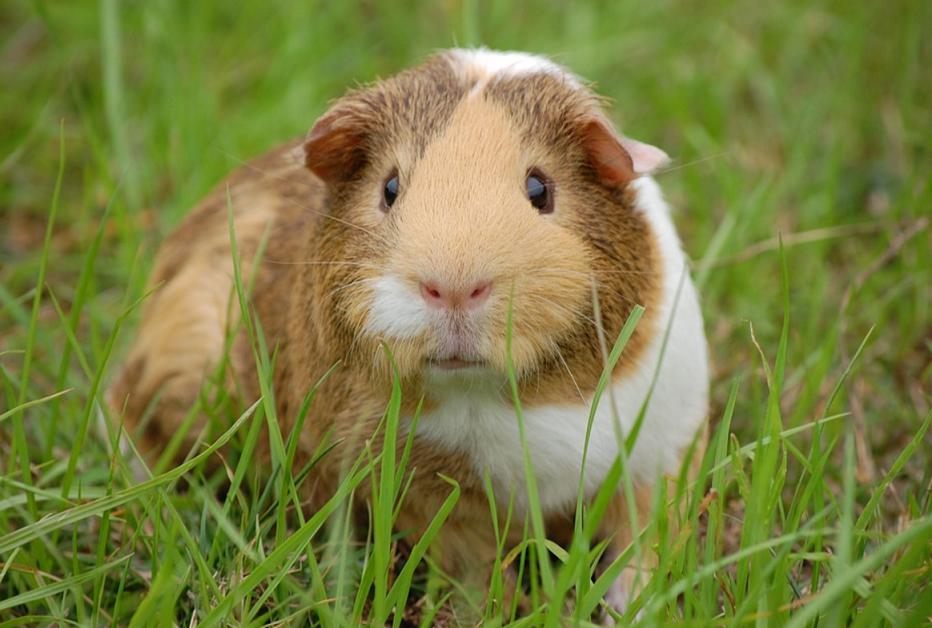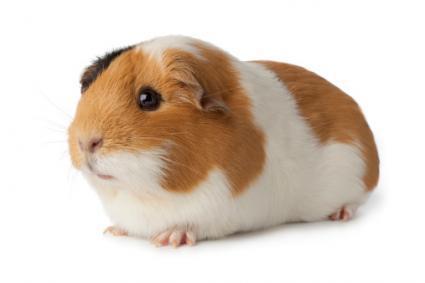The first image is the image on the left, the second image is the image on the right. Considering the images on both sides, is "At least one hamster is eating something in at least one of the images." valid? Answer yes or no. No. The first image is the image on the left, the second image is the image on the right. For the images shown, is this caption "Each image contains a single guinea pig and only one guinea pig is standing on green grass." true? Answer yes or no. Yes. 